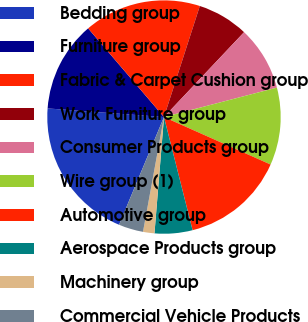<chart> <loc_0><loc_0><loc_500><loc_500><pie_chart><fcel>Bedding group<fcel>Furniture group<fcel>Fabric & Carpet Cushion group<fcel>Work Furniture group<fcel>Consumer Products group<fcel>Wire group (1)<fcel>Automotive group<fcel>Aerospace Products group<fcel>Machinery group<fcel>Commercial Vehicle Products<nl><fcel>19.89%<fcel>12.56%<fcel>16.23%<fcel>7.07%<fcel>8.9%<fcel>10.73%<fcel>14.39%<fcel>5.24%<fcel>1.58%<fcel>3.41%<nl></chart> 